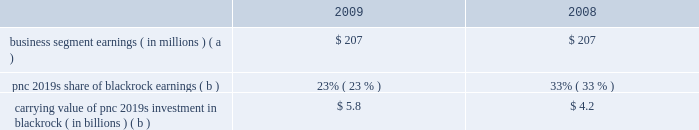Blackrock information related to our equity investment in blackrock follows: .
Carrying value of pnc 2019s investment in blackrock ( in billions ) ( b ) $ 5.8 $ 4.2 ( a ) includes pnc 2019s share of blackrock 2019s reported gaap earnings and additional income taxes on those earnings incurred by pnc .
( b ) at december 31 .
Blackrock/barclays global investors transaction on december 1 , 2009 , blackrock acquired bgi from barclays bank plc in exchange for approximately $ 6.65 billion in cash and 37566771 shares of blackrock common and participating preferred stock .
In connection with the bgi transaction , blackrock entered into amendments to stockholder agreements with pnc and its other major shareholder .
These amendments , which changed certain shareholder rights , including composition of the blackrock board of directors and share transfer restrictions , became effective upon closing of the bgi transaction .
Also in connection with the bgi transaction , blackrock entered into a stock purchase agreement with pnc in which we purchased 3556188 shares of blackrock 2019s series d preferred stock at a price of $ 140.60 per share , or $ 500 million , to partially finance the transaction .
On january 31 , 2010 , the series d preferred stock was converted to series b preferred stock .
Upon closing of the bgi transaction , the carrying value of our investment in blackrock increased significantly , reflecting our portion of the increase in blackrock 2019s equity resulting from the value of blackrock shares issued in connection with their acquisition of bgi .
Pnc recognized this increase in value as a $ 1.076 billion pretax gain in the fourth quarter of 2009 .
At december 31 , 2009 , our percentage ownership of blackrock common stock was approximately 35% ( 35 % ) .
Blackrock ltip programs and exchange agreements pnc 2019s noninterest income included pretax gains of $ 98 million in 2009 and $ 243 million in 2008 related to our blackrock ltip shares obligation .
These gains represented the mark-to-market adjustment related to our remaining blackrock ltip common shares obligation and resulted from the decrease in the market value of blackrock common shares in those periods .
As previously reported , pnc entered into an exchange agreement with blackrock on december 26 , 2008 .
The transactions that resulted from this agreement restructured pnc 2019s ownership of blackrock equity without altering , to any meaningful extent , pnc 2019s economic interest in blackrock .
Pnc continues to be subject to the limitations on its voting rights in its existing agreements with blackrock .
Also on december 26 , 2008 , blackrock entered into an exchange agreement with merrill lynch in anticipation of the consummation of the merger of bank of america corporation and merrill lynch that occurred on january 1 , 2009 .
The pnc and merrill lynch exchange agreements restructured pnc 2019s and merrill lynch 2019s respective ownership of blackrock common and preferred equity .
The exchange contemplated by these agreements was completed on february 27 , 2009 .
On that date , pnc 2019s obligation to deliver blackrock common shares was replaced with an obligation to deliver shares of blackrock 2019s new series c preferred stock .
Pnc acquired 2.9 million shares of series c preferred stock from blackrock in exchange for common shares on that same date .
Pnc accounts for these preferred shares at fair value , which offsets the impact of marking-to-market the obligation to deliver these shares to blackrock as we aligned the fair value marks on this asset and liability .
The fair value of the blackrock series c preferred stock is included on our consolidated balance sheet in other assets .
Additional information regarding the valuation of the blackrock series c preferred stock is included in note 8 fair value in the notes to consolidated financial statements included in item 8 of this report .
Pnc accounts for its remaining investment in blackrock under the equity method of accounting , with its share of blackrock 2019s earnings reduced primarily due to the exchange of blackrock common stock for blackrock series c preferred stock .
The series c preferred stock is not taken into consideration in determining pnc 2019s share of blackrock earnings under the equity method .
Pnc 2019s percentage ownership of blackrock common stock increased as a result of the substantial exchange of merrill lynch 2019s blackrock common stock for blackrock preferred stock .
As a result of the blackrock preferred stock held by merrill lynch and the new blackrock preferred stock issued to merrill lynch and pnc under the exchange agreements , pnc 2019s share of blackrock common stock is higher than its overall share of blackrock 2019s equity and earnings .
The transactions related to the exchange agreements do not affect our right to receive dividends declared by blackrock. .
What was pnc's total carrying value from 2008-09 from its investment in blackrock , in billions? 
Computations: (5.8 + 4.2)
Answer: 10.0. Blackrock information related to our equity investment in blackrock follows: .
Carrying value of pnc 2019s investment in blackrock ( in billions ) ( b ) $ 5.8 $ 4.2 ( a ) includes pnc 2019s share of blackrock 2019s reported gaap earnings and additional income taxes on those earnings incurred by pnc .
( b ) at december 31 .
Blackrock/barclays global investors transaction on december 1 , 2009 , blackrock acquired bgi from barclays bank plc in exchange for approximately $ 6.65 billion in cash and 37566771 shares of blackrock common and participating preferred stock .
In connection with the bgi transaction , blackrock entered into amendments to stockholder agreements with pnc and its other major shareholder .
These amendments , which changed certain shareholder rights , including composition of the blackrock board of directors and share transfer restrictions , became effective upon closing of the bgi transaction .
Also in connection with the bgi transaction , blackrock entered into a stock purchase agreement with pnc in which we purchased 3556188 shares of blackrock 2019s series d preferred stock at a price of $ 140.60 per share , or $ 500 million , to partially finance the transaction .
On january 31 , 2010 , the series d preferred stock was converted to series b preferred stock .
Upon closing of the bgi transaction , the carrying value of our investment in blackrock increased significantly , reflecting our portion of the increase in blackrock 2019s equity resulting from the value of blackrock shares issued in connection with their acquisition of bgi .
Pnc recognized this increase in value as a $ 1.076 billion pretax gain in the fourth quarter of 2009 .
At december 31 , 2009 , our percentage ownership of blackrock common stock was approximately 35% ( 35 % ) .
Blackrock ltip programs and exchange agreements pnc 2019s noninterest income included pretax gains of $ 98 million in 2009 and $ 243 million in 2008 related to our blackrock ltip shares obligation .
These gains represented the mark-to-market adjustment related to our remaining blackrock ltip common shares obligation and resulted from the decrease in the market value of blackrock common shares in those periods .
As previously reported , pnc entered into an exchange agreement with blackrock on december 26 , 2008 .
The transactions that resulted from this agreement restructured pnc 2019s ownership of blackrock equity without altering , to any meaningful extent , pnc 2019s economic interest in blackrock .
Pnc continues to be subject to the limitations on its voting rights in its existing agreements with blackrock .
Also on december 26 , 2008 , blackrock entered into an exchange agreement with merrill lynch in anticipation of the consummation of the merger of bank of america corporation and merrill lynch that occurred on january 1 , 2009 .
The pnc and merrill lynch exchange agreements restructured pnc 2019s and merrill lynch 2019s respective ownership of blackrock common and preferred equity .
The exchange contemplated by these agreements was completed on february 27 , 2009 .
On that date , pnc 2019s obligation to deliver blackrock common shares was replaced with an obligation to deliver shares of blackrock 2019s new series c preferred stock .
Pnc acquired 2.9 million shares of series c preferred stock from blackrock in exchange for common shares on that same date .
Pnc accounts for these preferred shares at fair value , which offsets the impact of marking-to-market the obligation to deliver these shares to blackrock as we aligned the fair value marks on this asset and liability .
The fair value of the blackrock series c preferred stock is included on our consolidated balance sheet in other assets .
Additional information regarding the valuation of the blackrock series c preferred stock is included in note 8 fair value in the notes to consolidated financial statements included in item 8 of this report .
Pnc accounts for its remaining investment in blackrock under the equity method of accounting , with its share of blackrock 2019s earnings reduced primarily due to the exchange of blackrock common stock for blackrock series c preferred stock .
The series c preferred stock is not taken into consideration in determining pnc 2019s share of blackrock earnings under the equity method .
Pnc 2019s percentage ownership of blackrock common stock increased as a result of the substantial exchange of merrill lynch 2019s blackrock common stock for blackrock preferred stock .
As a result of the blackrock preferred stock held by merrill lynch and the new blackrock preferred stock issued to merrill lynch and pnc under the exchange agreements , pnc 2019s share of blackrock common stock is higher than its overall share of blackrock 2019s equity and earnings .
The transactions related to the exchange agreements do not affect our right to receive dividends declared by blackrock. .
The recognized increase in value as a pretax gain in the fourth quarter of 2009 equaled what percent of the total carrying value of pnc 2019s investment in blackrock? 
Computations: (1.076 / 5)
Answer: 0.2152. 